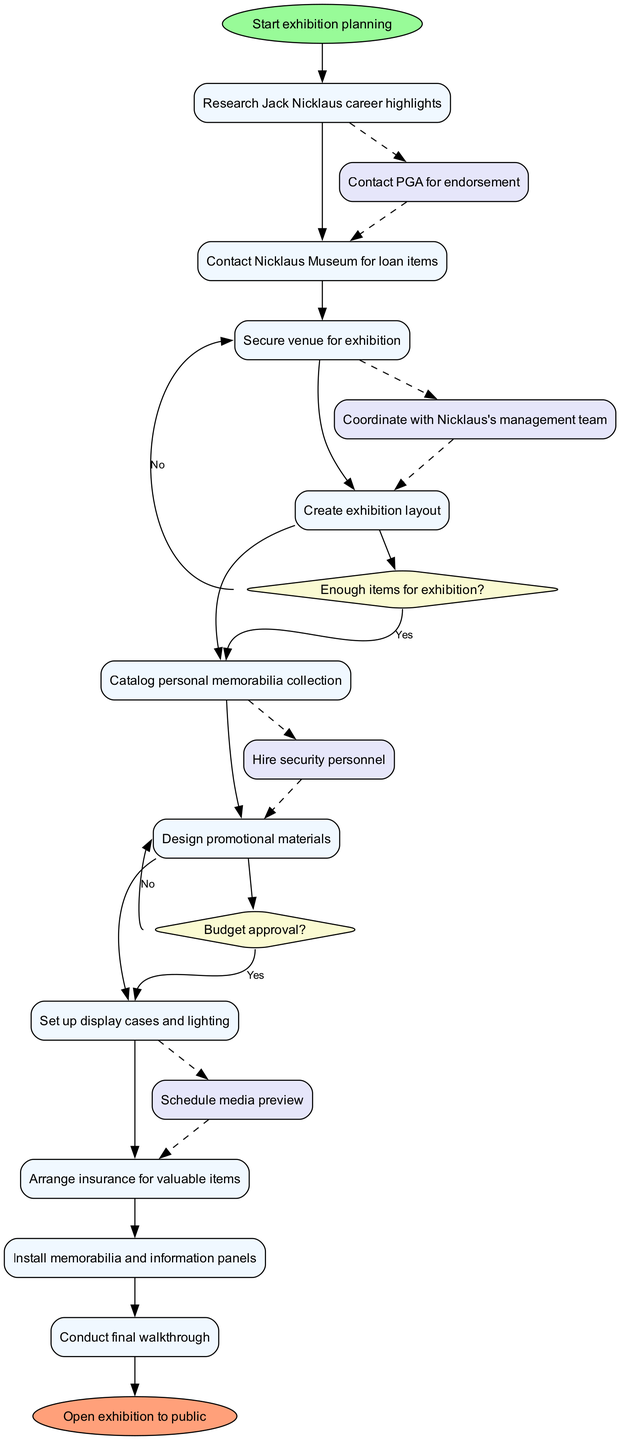What is the initial activity in the diagram? The initial activity is labeled as "Start exhibition planning" and is represented by the initial node in the diagram, which begins the flow of activities.
Answer: Start exhibition planning How many activities are included in the diagram? The diagram lists a total of 10 activities, including the initial activity and the final activity, which refer to specific steps in the exhibition organization process.
Answer: 10 What decision follows the activity "Create exhibition layout"? The decision following "Create exhibition layout" is "Enough items for exhibition?", as indicated by the flow from this activity to the decision node.
Answer: Enough items for exhibition? What happens if the budget is not approved? If the budget is not approved, the process will flow to "Revise budget proposal," as shown by the diagram's edge leading from the decision "Budget approval?" labeled "No."
Answer: Revise budget proposal What is the final node of the diagram? The final node of the diagram is labeled as "Open exhibition to public," indicating the endpoint of the exhibition organization process after all activities are completed.
Answer: Open exhibition to public Which activity comes after "Design promotional materials"? The activity that follows "Design promotional materials" is "Set up display cases and lighting," as indicated in the diagram’s sequence of activities.
Answer: Set up display cases and lighting If the answer to "Enough items for exhibition?" is yes, what is the next activity? If the answer is yes, the next activity would be "Catalog personal memorabilia collection," as per the flow from the decision node labeled with this condition.
Answer: Catalog personal memorabilia collection What activity is connected to "Contact PGA for endorsement"? The activity connected to "Contact PGA for endorsement" is "Coordinate with Nicklaus's management team," as shown by the dashed edges linking these two activities in the diagram.
Answer: Coordinate with Nicklaus's management team Which edge shows the step of hiring security personnel? The edge that shows the step of hiring security personnel leads from the activity "Arrange insurance for valuable items" to "Schedule media preview," representing the continuity of organizing the exhibition.
Answer: Schedule media preview 